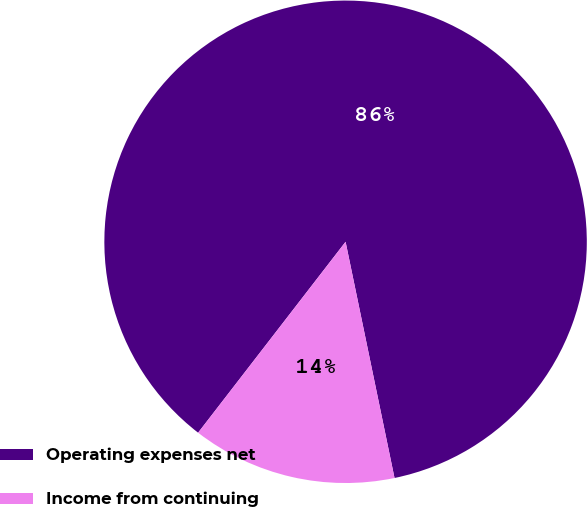Convert chart to OTSL. <chart><loc_0><loc_0><loc_500><loc_500><pie_chart><fcel>Operating expenses net<fcel>Income from continuing<nl><fcel>86.28%<fcel>13.72%<nl></chart> 